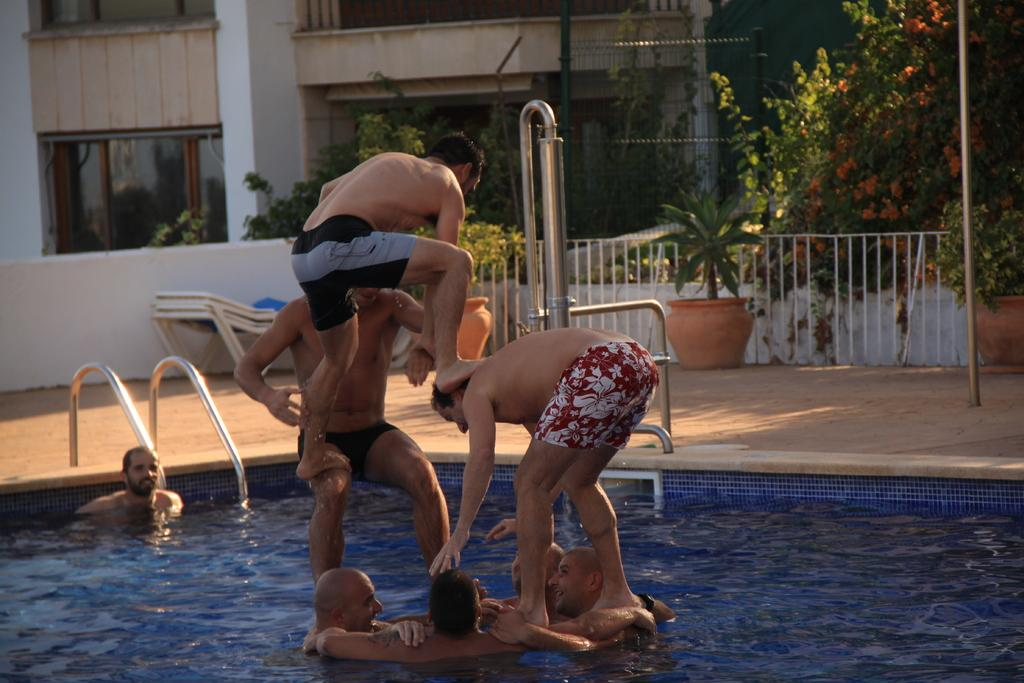What type of structure is visible in the image? There is a building in the image. What other natural elements can be seen in the image? There are trees in the image. Are there any plants visible in the image? Yes, there are plants in pots in the image. What activity are some men engaged in within the image? Some men are in a swimming pool in the image. Can you describe the interaction between the men in the swimming pool? Some men are standing on top of others in the image. What type of bone can be seen in the image? There is no bone present in the image. Where is the spot where the party is taking place in the image? There is no party mentioned or depicted in the image. 